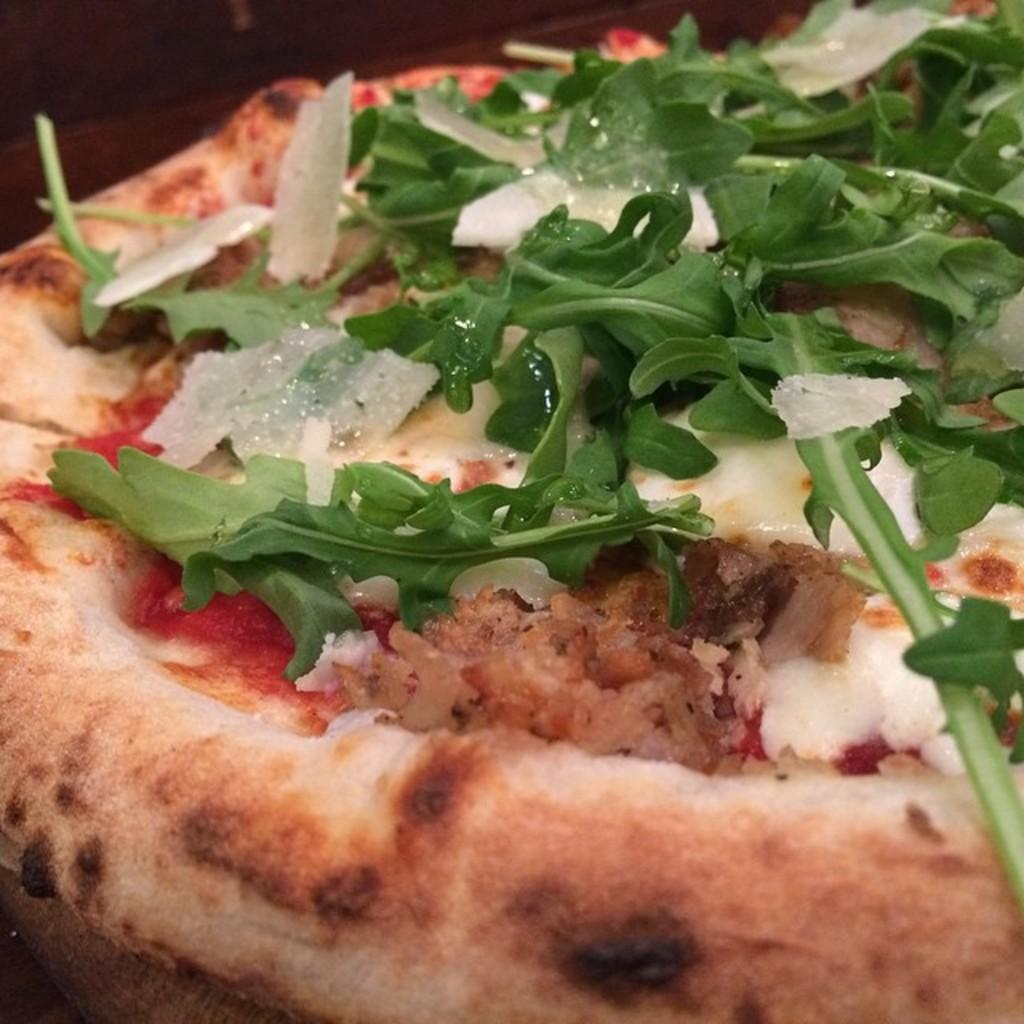What type of food is shown in the image? There is a pizza in the image. What is on top of the pizza? The pizza is topped with parsley. Where is the pizza located? The pizza is placed on a table. What type of bulb is used to light up the airport in the image? There is no airport or bulb present in the image; it features a pizza with parsley on a table. 